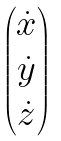<formula> <loc_0><loc_0><loc_500><loc_500>\begin{pmatrix} \dot { x } \\ \dot { y } \\ \dot { z } \end{pmatrix}</formula> 